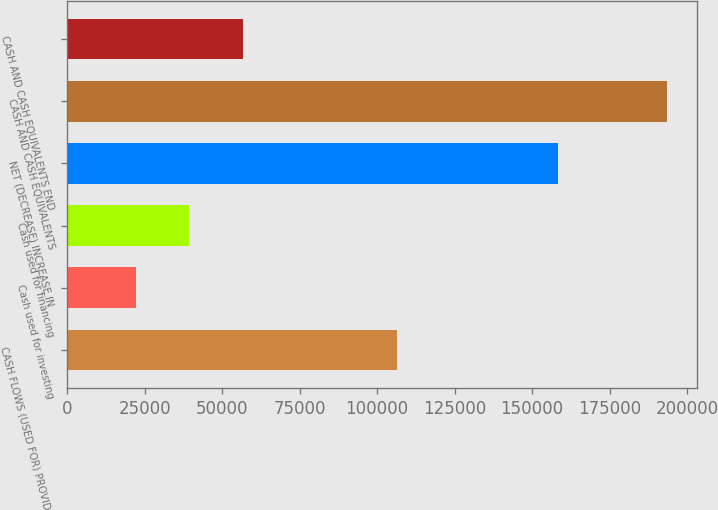<chart> <loc_0><loc_0><loc_500><loc_500><bar_chart><fcel>CASH FLOWS (USED FOR) PROVIDED<fcel>Cash used for investing<fcel>Cash used for financing<fcel>NET (DECREASE) INCREASE IN<fcel>CASH AND CASH EQUIVALENTS<fcel>CASH AND CASH EQUIVALENTS END<nl><fcel>106391<fcel>22349<fcel>39462.4<fcel>158473<fcel>193483<fcel>56575.8<nl></chart> 